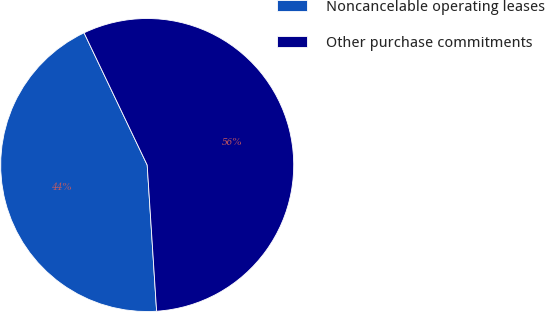Convert chart. <chart><loc_0><loc_0><loc_500><loc_500><pie_chart><fcel>Noncancelable operating leases<fcel>Other purchase commitments<nl><fcel>43.93%<fcel>56.07%<nl></chart> 